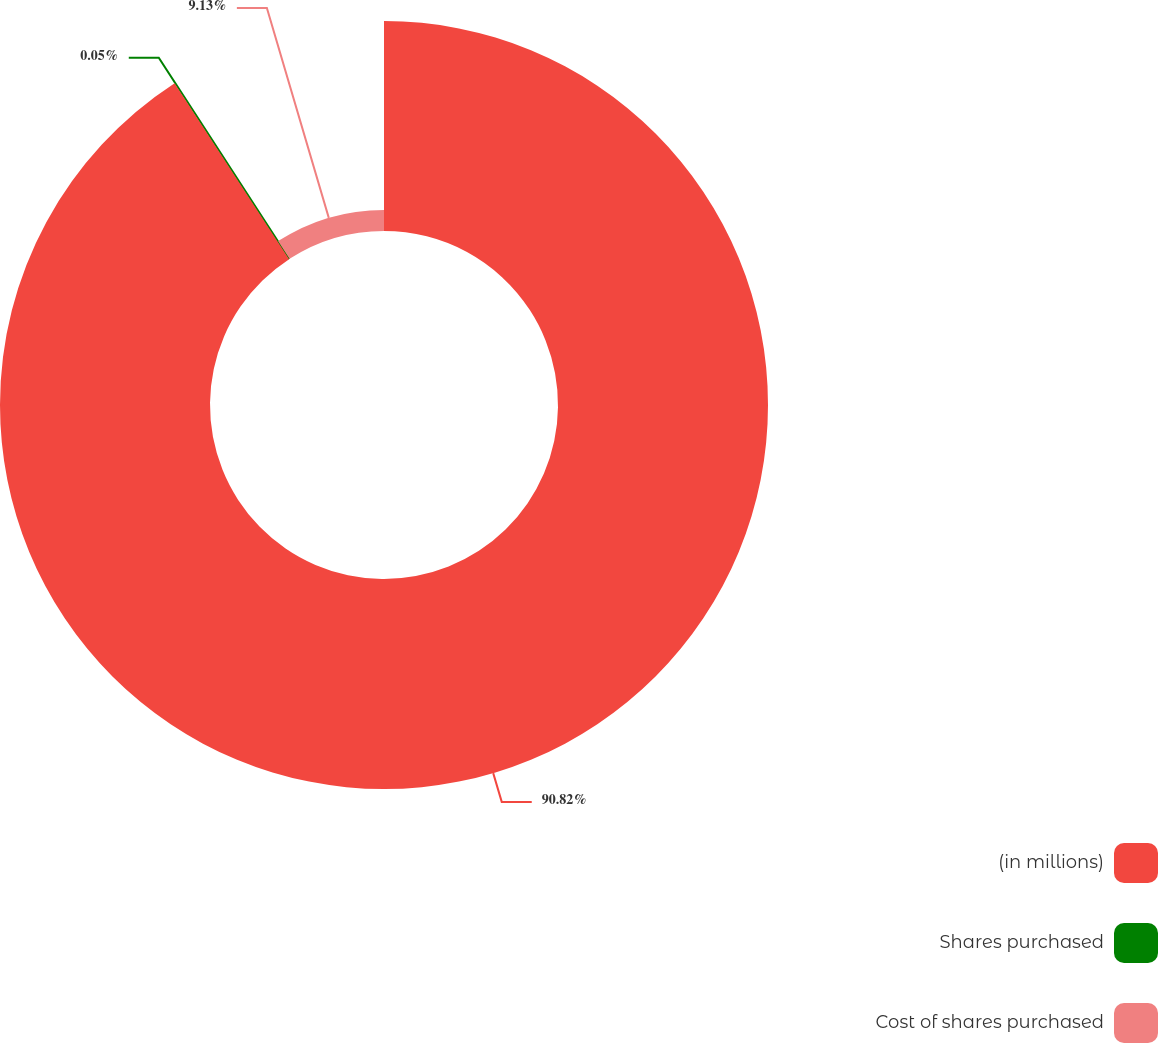<chart> <loc_0><loc_0><loc_500><loc_500><pie_chart><fcel>(in millions)<fcel>Shares purchased<fcel>Cost of shares purchased<nl><fcel>90.82%<fcel>0.05%<fcel>9.13%<nl></chart> 